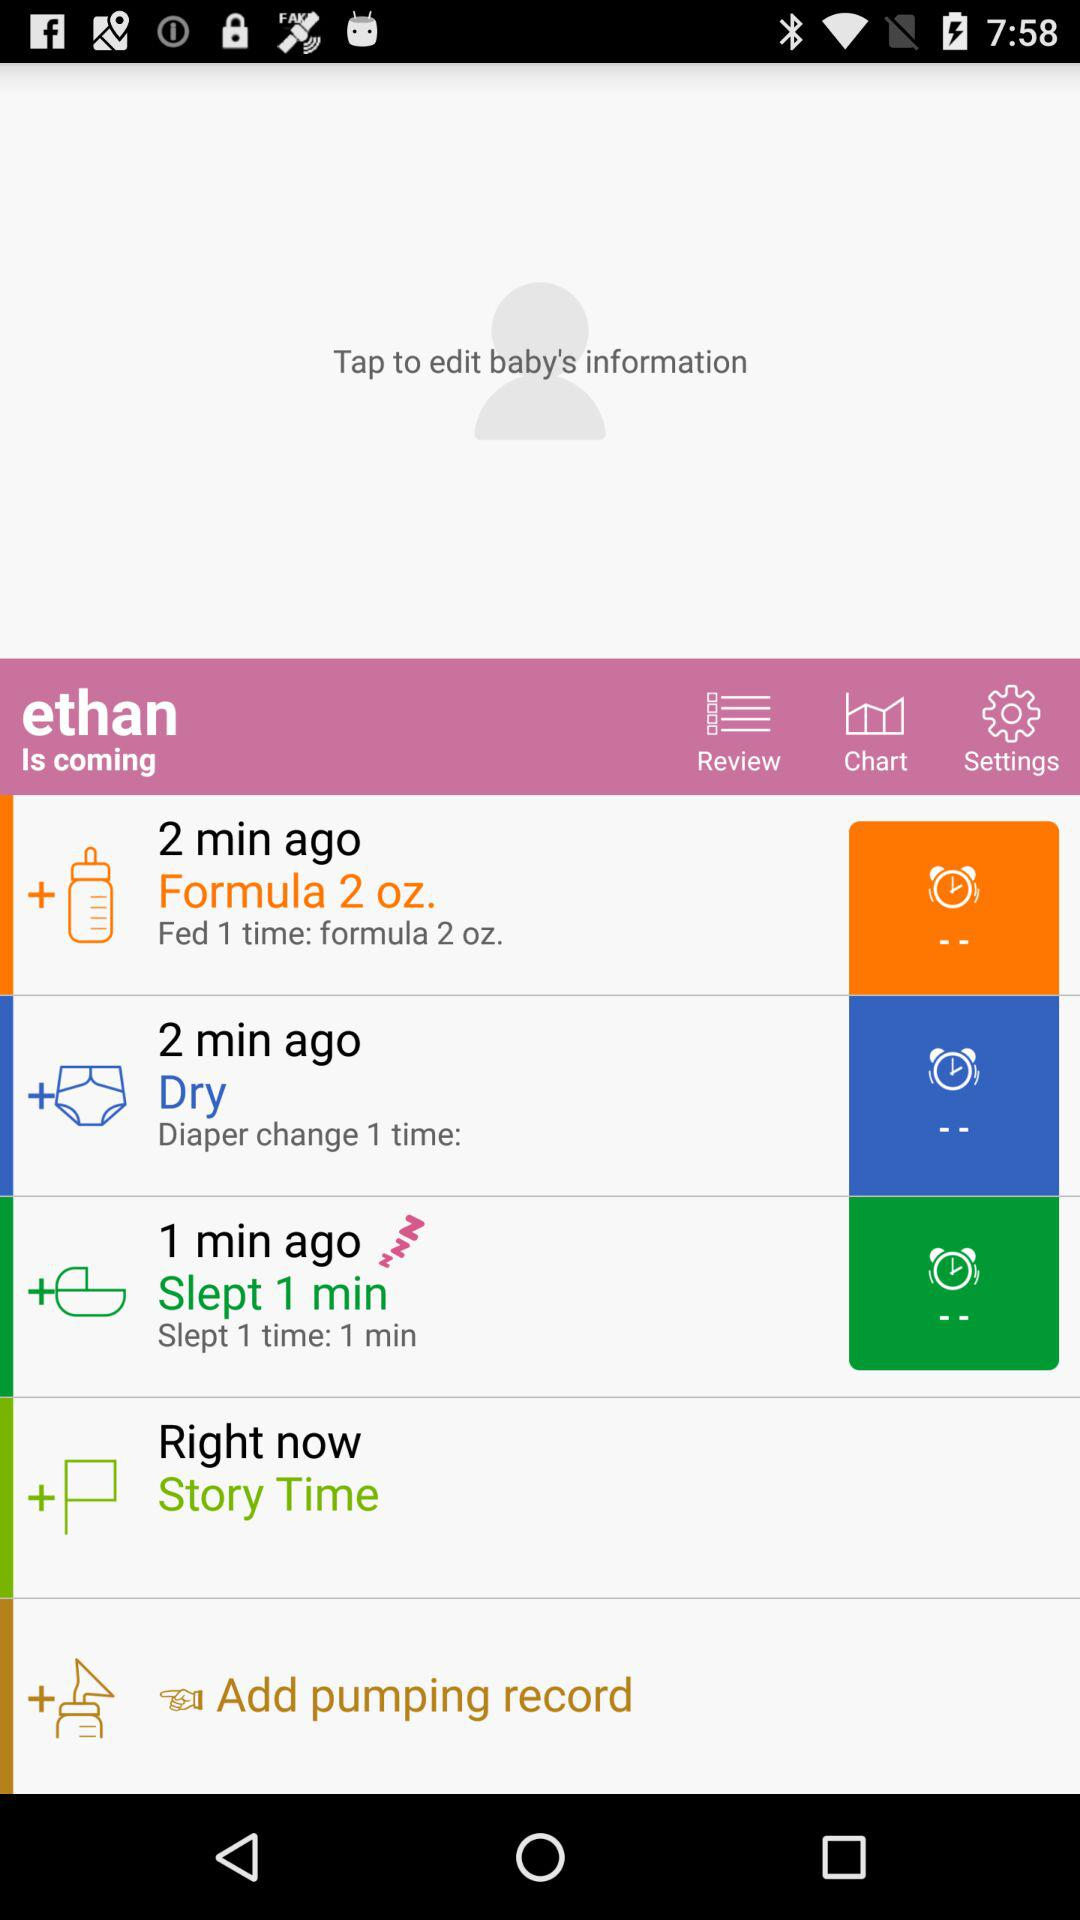When did the baby sleep? The baby slept 1 minute ago. 